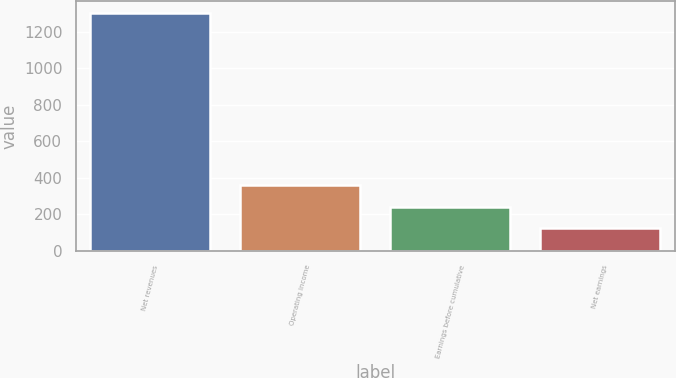Convert chart. <chart><loc_0><loc_0><loc_500><loc_500><bar_chart><fcel>Net revenues<fcel>Operating income<fcel>Earnings before cumulative<fcel>Net earnings<nl><fcel>1303.5<fcel>359.9<fcel>241.95<fcel>124<nl></chart> 